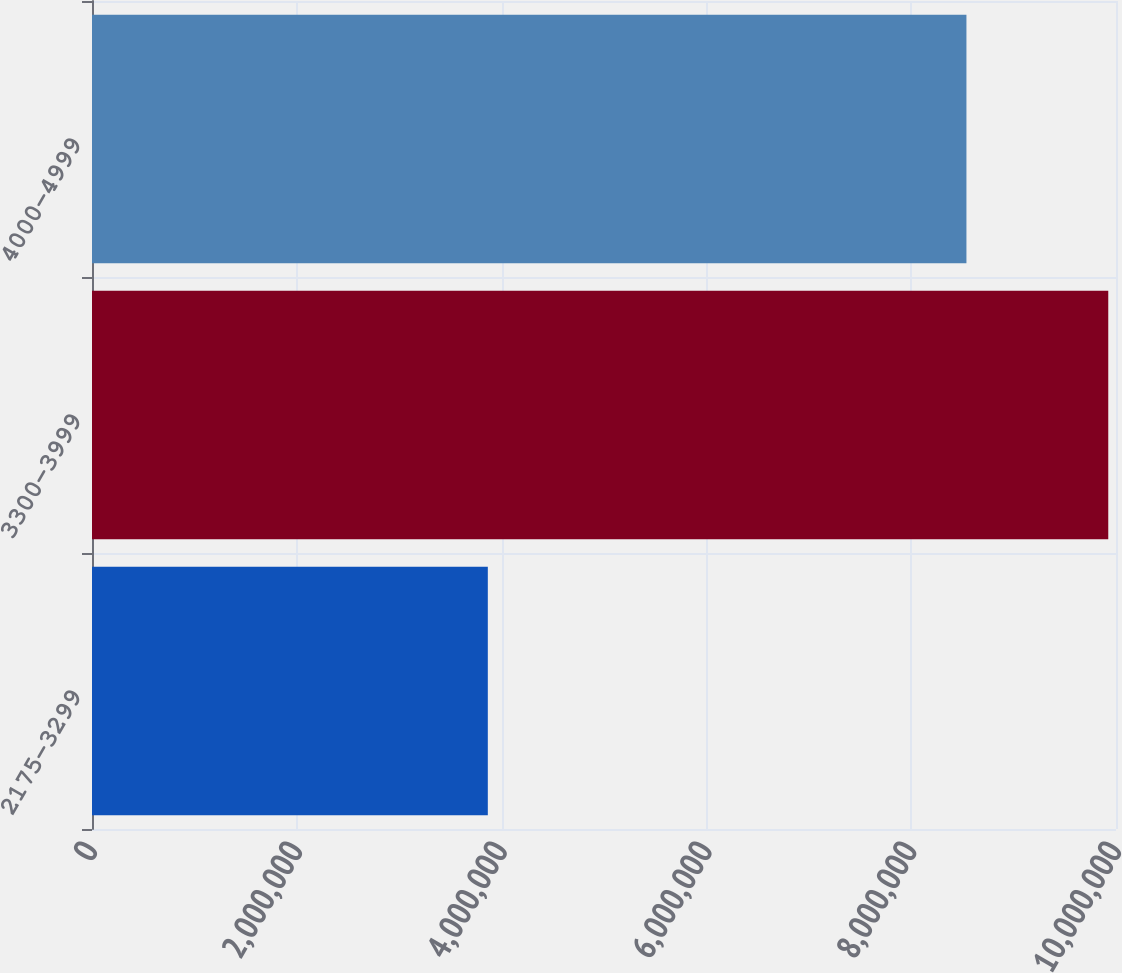Convert chart. <chart><loc_0><loc_0><loc_500><loc_500><bar_chart><fcel>2175-3299<fcel>3300-3999<fcel>4000-4999<nl><fcel>3.86536e+06<fcel>9.92447e+06<fcel>8.53944e+06<nl></chart> 